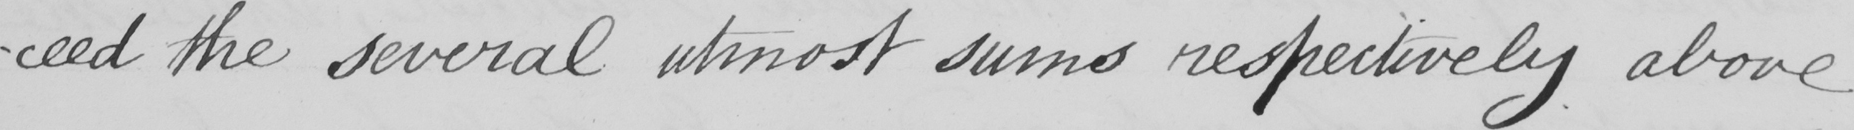What text is written in this handwritten line? -ceed the several utmost sums respectively above 